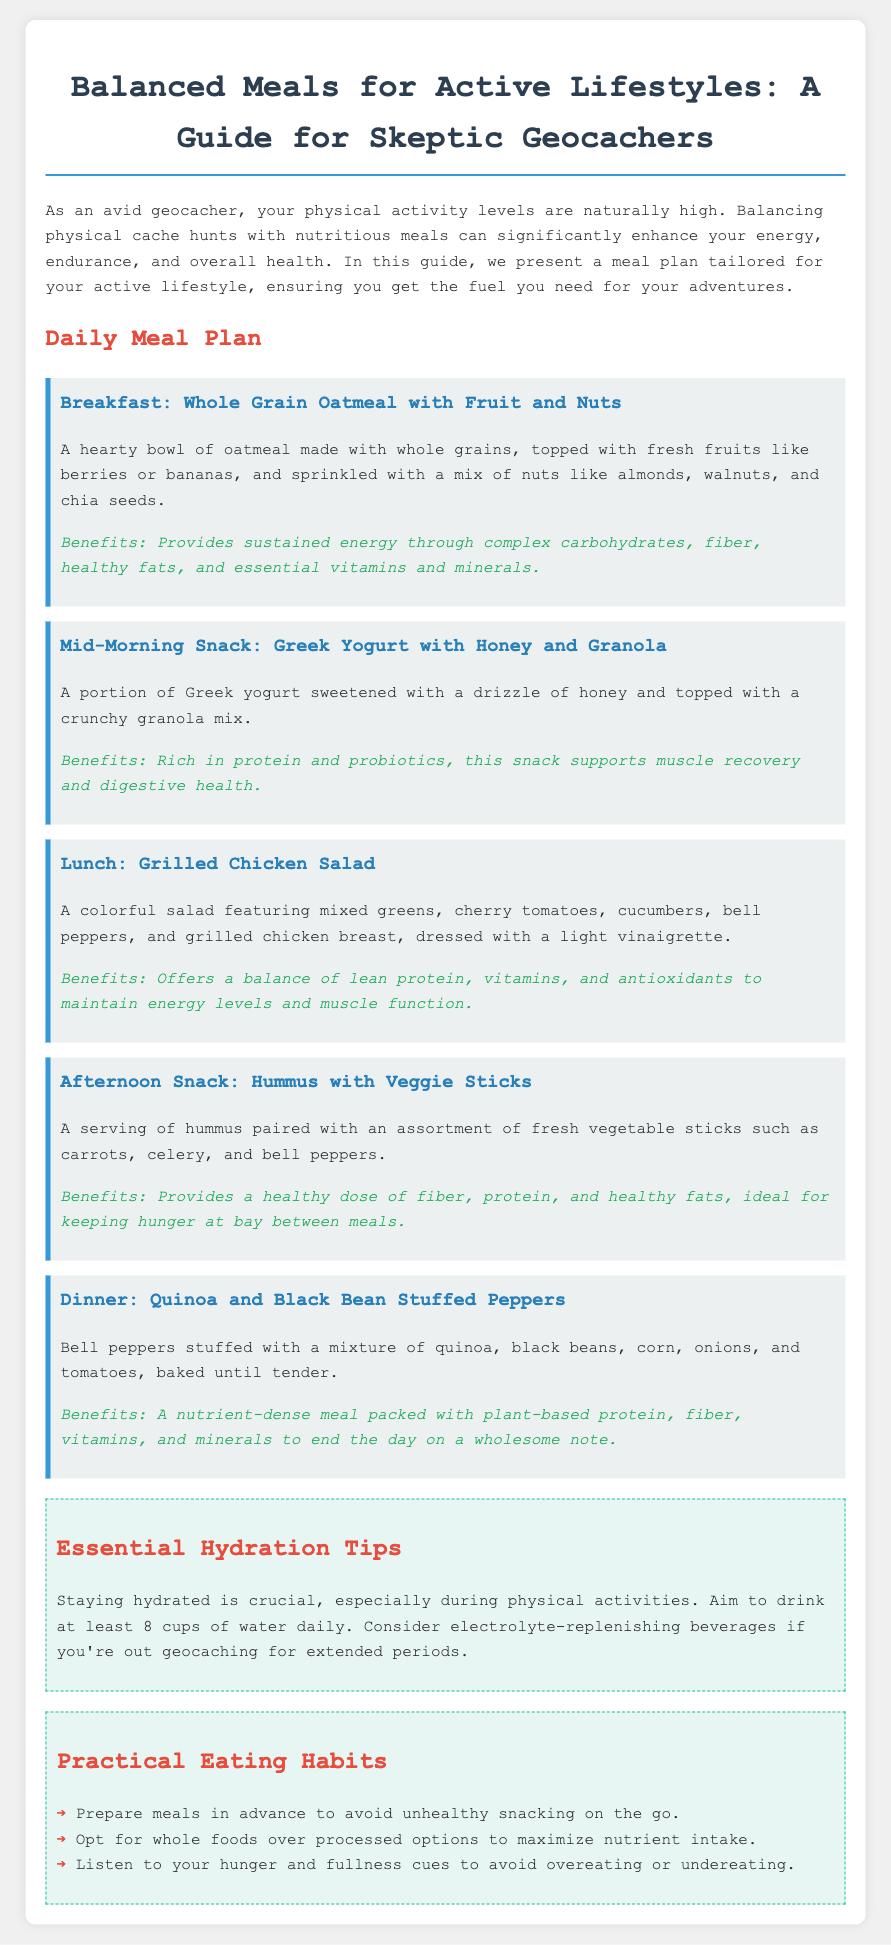What is the first meal in the daily plan? The first meal mentioned is breakfast, specifically "Whole Grain Oatmeal with Fruit and Nuts."
Answer: Whole Grain Oatmeal with Fruit and Nuts What is a key ingredient in the lunch meal? The lunch meal is a Grilled Chicken Salad, which notably includes grilled chicken breast as a key ingredient.
Answer: Grilled chicken breast How many cups of water should one aim to drink daily? The document advises drinking at least 8 cups of water daily for proper hydration.
Answer: 8 cups What type of snack is recommended for the afternoon? The afternoon snack listed is "Hummus with Veggie Sticks."
Answer: Hummus with Veggie Sticks What is one benefit of having Greek yogurt as a snack? Greek yogurt provides rich protein and probiotics, beneficial for muscle recovery and digestive health.
Answer: Muscle recovery and digestive health What nutrient is highlighted in the breakfast meal? The breakfast meal emphasizes complex carbohydrates which provide sustained energy.
Answer: Complex carbohydrates What is the main source of protein in the dinner meal? The dinner meal features quinoa and black beans which serve as the main source of plant-based protein.
Answer: Quinoa and black beans What cooking method is used for the dinner meal? The dinner meal, Quinoa and Black Bean Stuffed Peppers, is baked until tender as noted in the description.
Answer: Baked How can one avoid unhealthy snacking according to the tips? Preparing meals in advance is suggested as a way to avoid unhealthy snacking.
Answer: Prepare meals in advance 